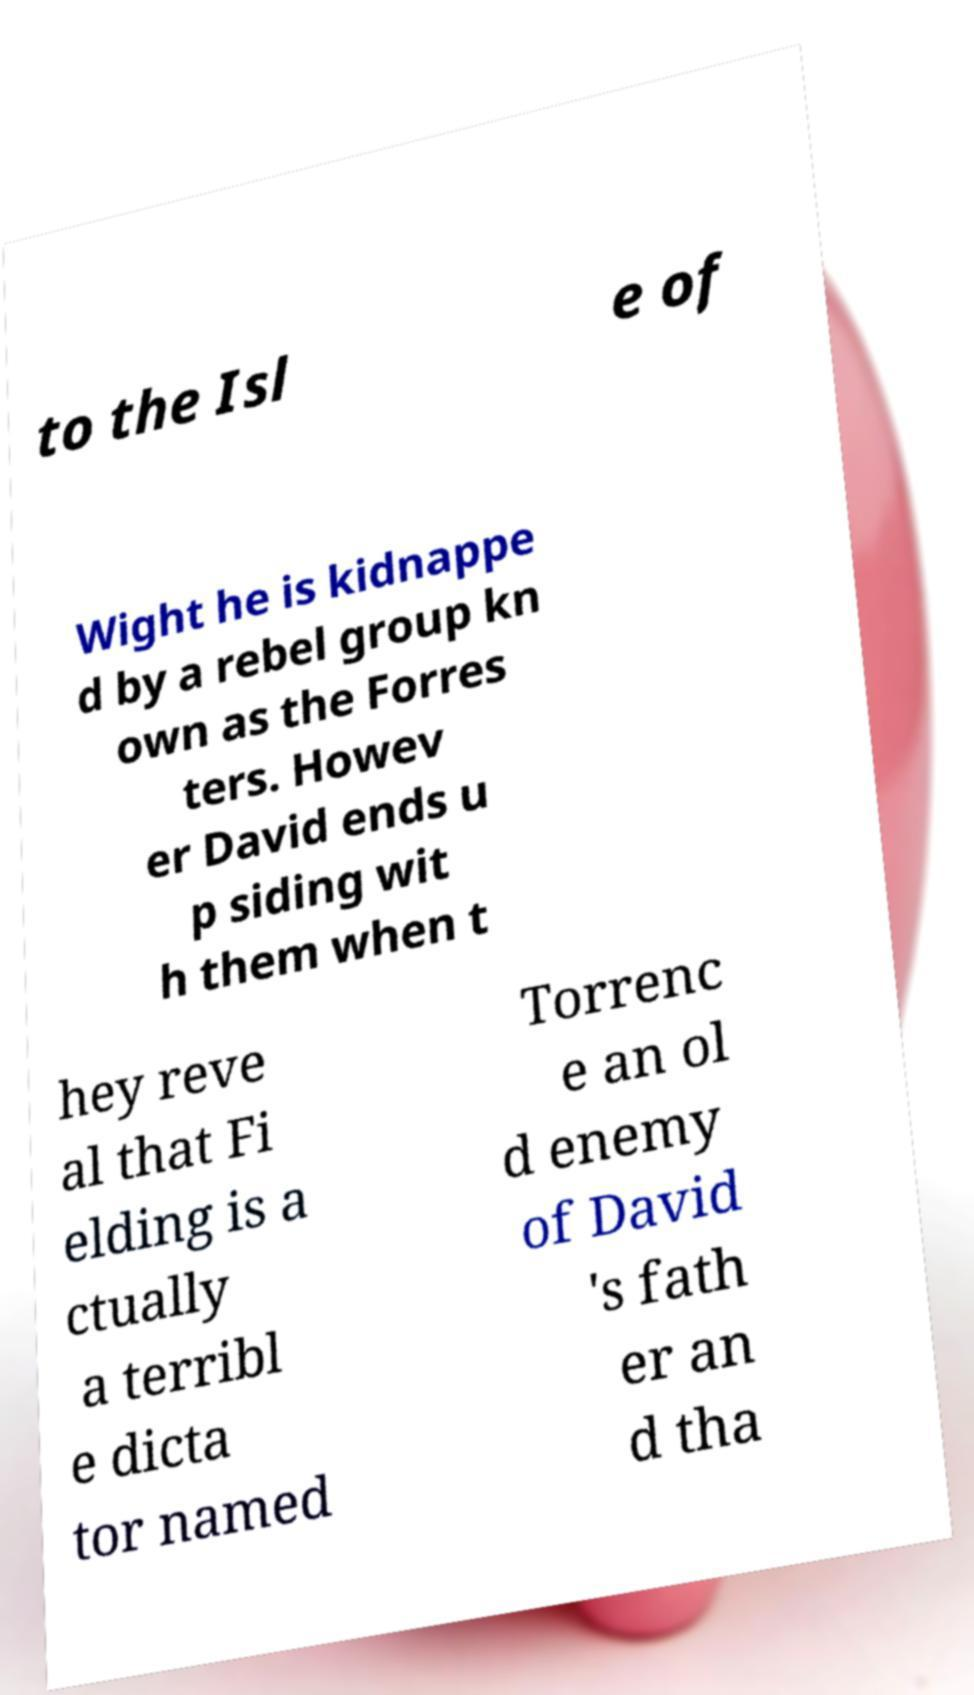What messages or text are displayed in this image? I need them in a readable, typed format. to the Isl e of Wight he is kidnappe d by a rebel group kn own as the Forres ters. Howev er David ends u p siding wit h them when t hey reve al that Fi elding is a ctually a terribl e dicta tor named Torrenc e an ol d enemy of David 's fath er an d tha 